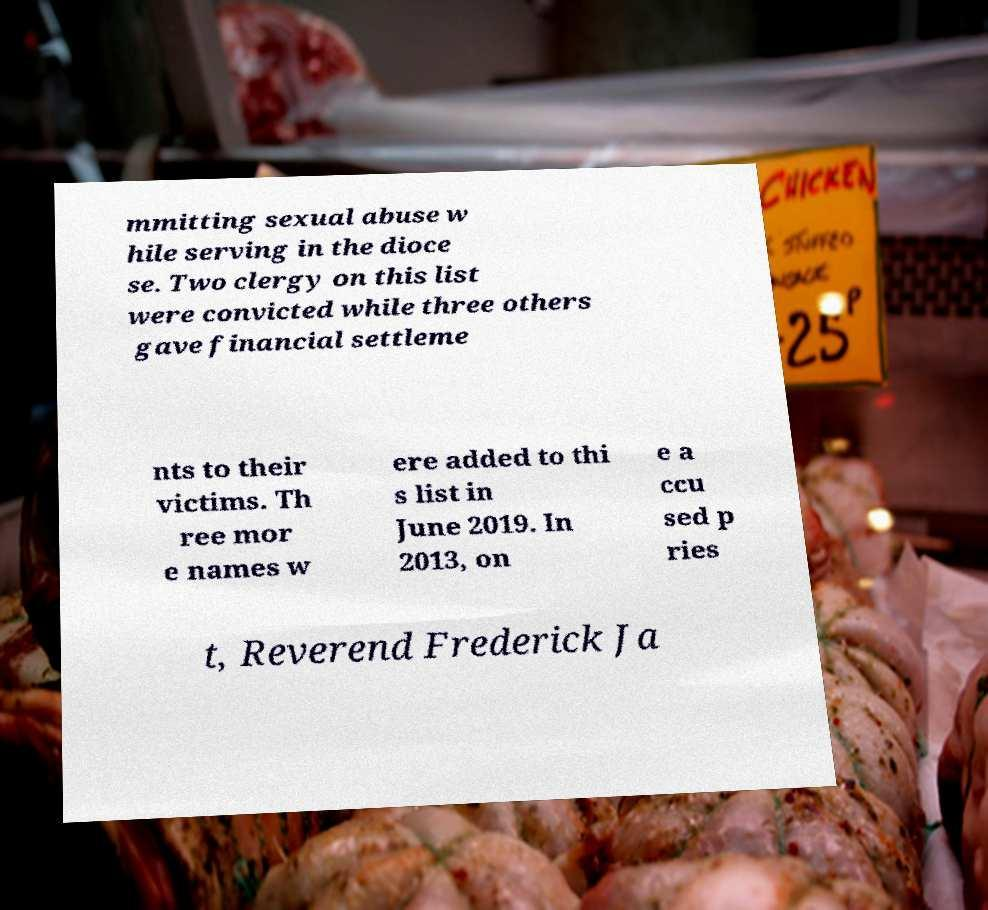I need the written content from this picture converted into text. Can you do that? mmitting sexual abuse w hile serving in the dioce se. Two clergy on this list were convicted while three others gave financial settleme nts to their victims. Th ree mor e names w ere added to thi s list in June 2019. In 2013, on e a ccu sed p ries t, Reverend Frederick Ja 